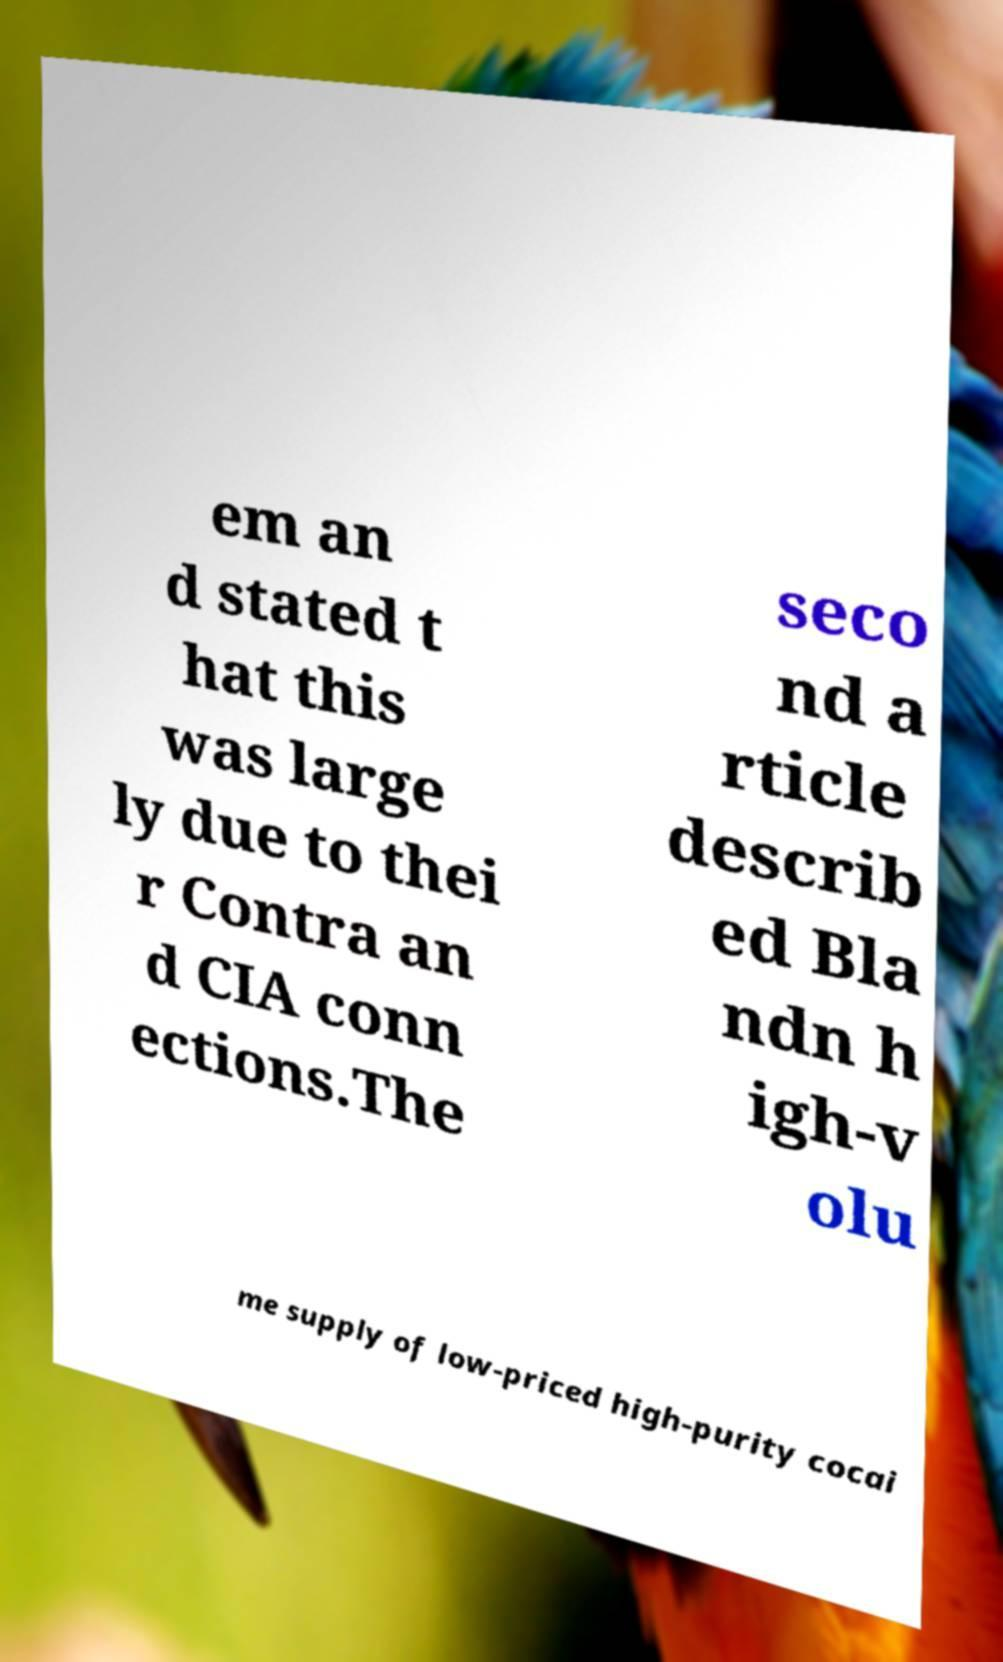There's text embedded in this image that I need extracted. Can you transcribe it verbatim? em an d stated t hat this was large ly due to thei r Contra an d CIA conn ections.The seco nd a rticle describ ed Bla ndn h igh-v olu me supply of low-priced high-purity cocai 